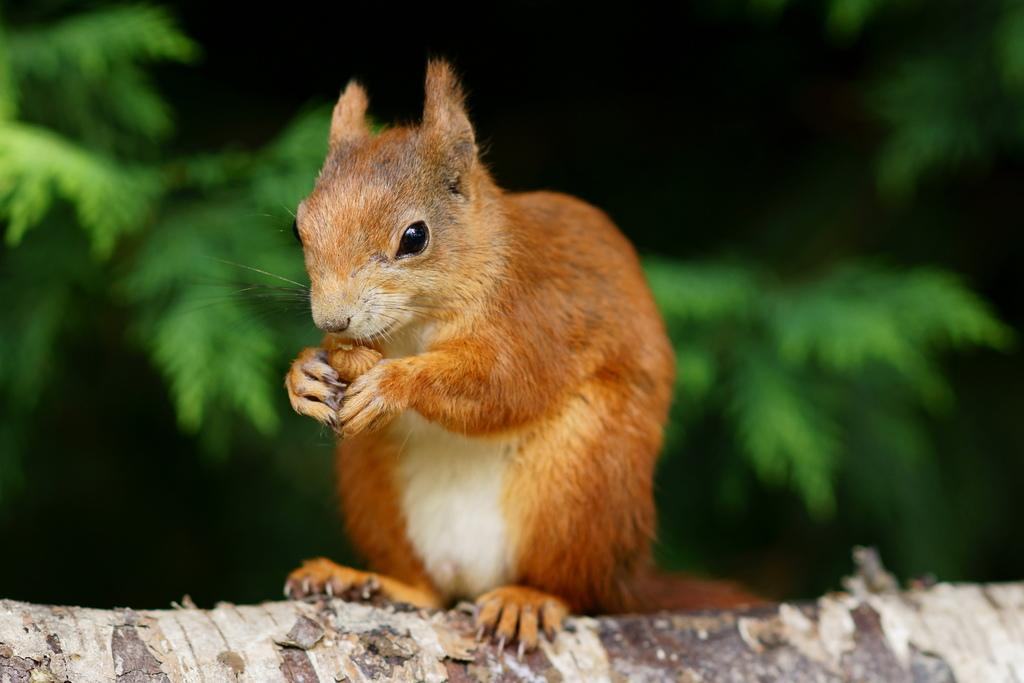What can be observed about the background of the image? The background portion of the picture is blurry. What type of vegetation is present in the image? There are green leaves visible. What animal is featured in the image? There is a squirrel in the image. Where is the squirrel located in the image? The squirrel is on a branch. Can you see any trains or cakes in the image? No, there are no trains or cakes present in the image. What type of ocean can be seen in the background of the image? There is no ocean visible in the image; the background is blurry and features green leaves. 